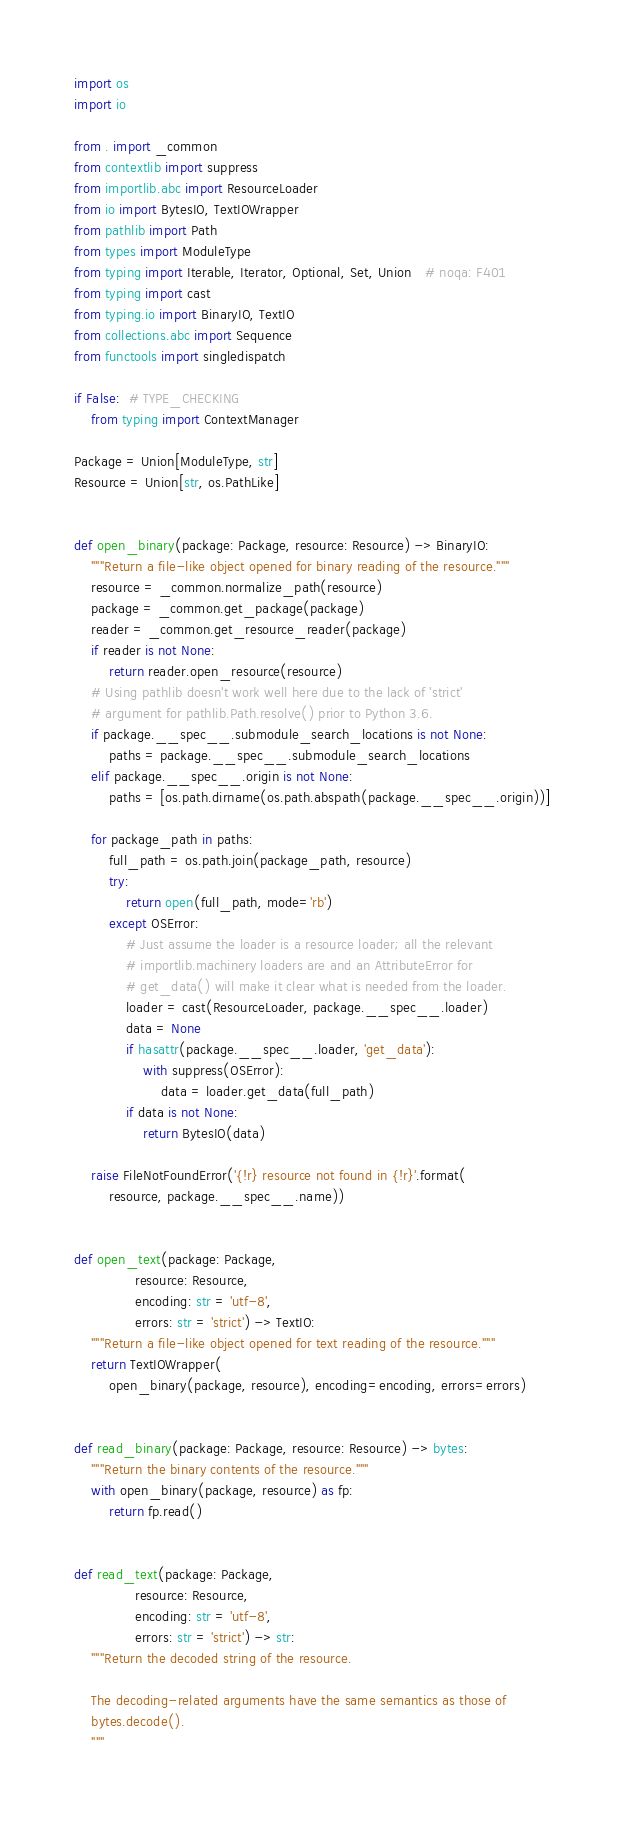<code> <loc_0><loc_0><loc_500><loc_500><_Python_>import os
import io

from . import _common
from contextlib import suppress
from importlib.abc import ResourceLoader
from io import BytesIO, TextIOWrapper
from pathlib import Path
from types import ModuleType
from typing import Iterable, Iterator, Optional, Set, Union   # noqa: F401
from typing import cast
from typing.io import BinaryIO, TextIO
from collections.abc import Sequence
from functools import singledispatch

if False:  # TYPE_CHECKING
    from typing import ContextManager

Package = Union[ModuleType, str]
Resource = Union[str, os.PathLike]


def open_binary(package: Package, resource: Resource) -> BinaryIO:
    """Return a file-like object opened for binary reading of the resource."""
    resource = _common.normalize_path(resource)
    package = _common.get_package(package)
    reader = _common.get_resource_reader(package)
    if reader is not None:
        return reader.open_resource(resource)
    # Using pathlib doesn't work well here due to the lack of 'strict'
    # argument for pathlib.Path.resolve() prior to Python 3.6.
    if package.__spec__.submodule_search_locations is not None:
        paths = package.__spec__.submodule_search_locations
    elif package.__spec__.origin is not None:
        paths = [os.path.dirname(os.path.abspath(package.__spec__.origin))]

    for package_path in paths:
        full_path = os.path.join(package_path, resource)
        try:
            return open(full_path, mode='rb')
        except OSError:
            # Just assume the loader is a resource loader; all the relevant
            # importlib.machinery loaders are and an AttributeError for
            # get_data() will make it clear what is needed from the loader.
            loader = cast(ResourceLoader, package.__spec__.loader)
            data = None
            if hasattr(package.__spec__.loader, 'get_data'):
                with suppress(OSError):
                    data = loader.get_data(full_path)
            if data is not None:
                return BytesIO(data)

    raise FileNotFoundError('{!r} resource not found in {!r}'.format(
        resource, package.__spec__.name))


def open_text(package: Package,
              resource: Resource,
              encoding: str = 'utf-8',
              errors: str = 'strict') -> TextIO:
    """Return a file-like object opened for text reading of the resource."""
    return TextIOWrapper(
        open_binary(package, resource), encoding=encoding, errors=errors)


def read_binary(package: Package, resource: Resource) -> bytes:
    """Return the binary contents of the resource."""
    with open_binary(package, resource) as fp:
        return fp.read()


def read_text(package: Package,
              resource: Resource,
              encoding: str = 'utf-8',
              errors: str = 'strict') -> str:
    """Return the decoded string of the resource.

    The decoding-related arguments have the same semantics as those of
    bytes.decode().
    """</code> 